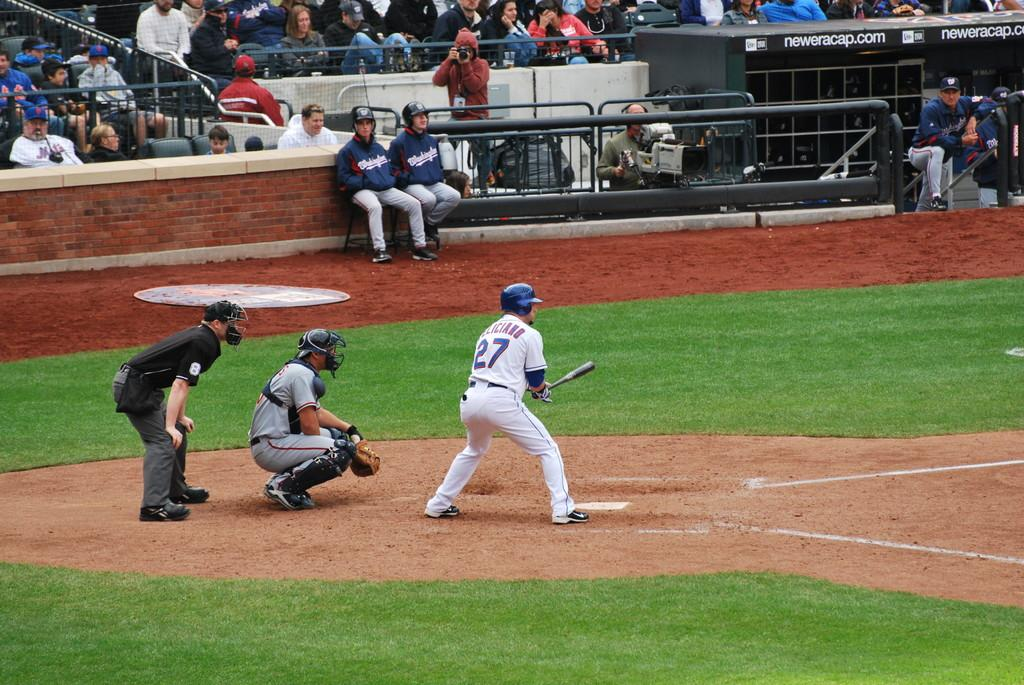<image>
Describe the image concisely. A baseball game is being played with number twenty seven up to bat. 